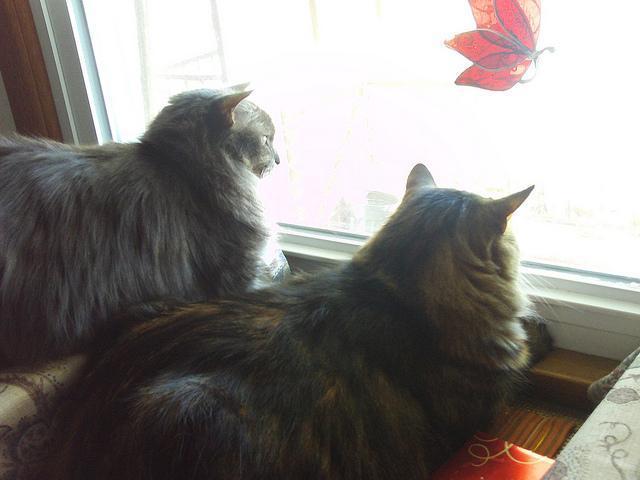How many cats are there?
Give a very brief answer. 2. 